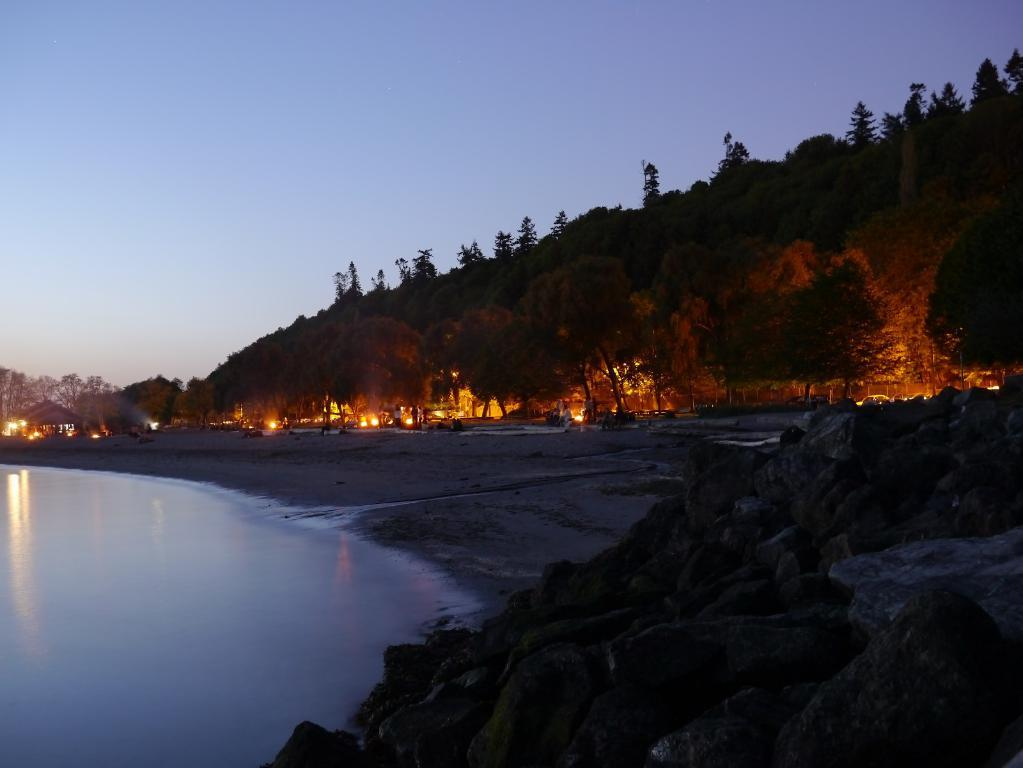What is one of the main elements in the image? There is water in the image. What type of natural vegetation can be seen in the image? There are trees in the image. What artificial light sources are present in the image? There are lights in the image. What is the color of the sky in the image? The sky is blue in color. What type of cord is being used to hold up the brass credit card in the image? There is no cord, brass, or credit card present in the image. 